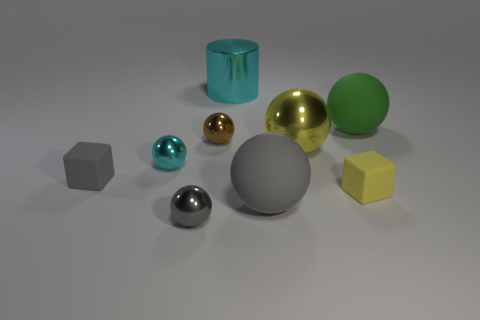There is a metal object that is both on the right side of the small brown object and in front of the green matte thing; what shape is it? The metal object positioned to the right of the small brown cube and in front of the green sphere is spherical in shape. 